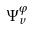Convert formula to latex. <formula><loc_0><loc_0><loc_500><loc_500>\Psi _ { v } ^ { \varphi }</formula> 